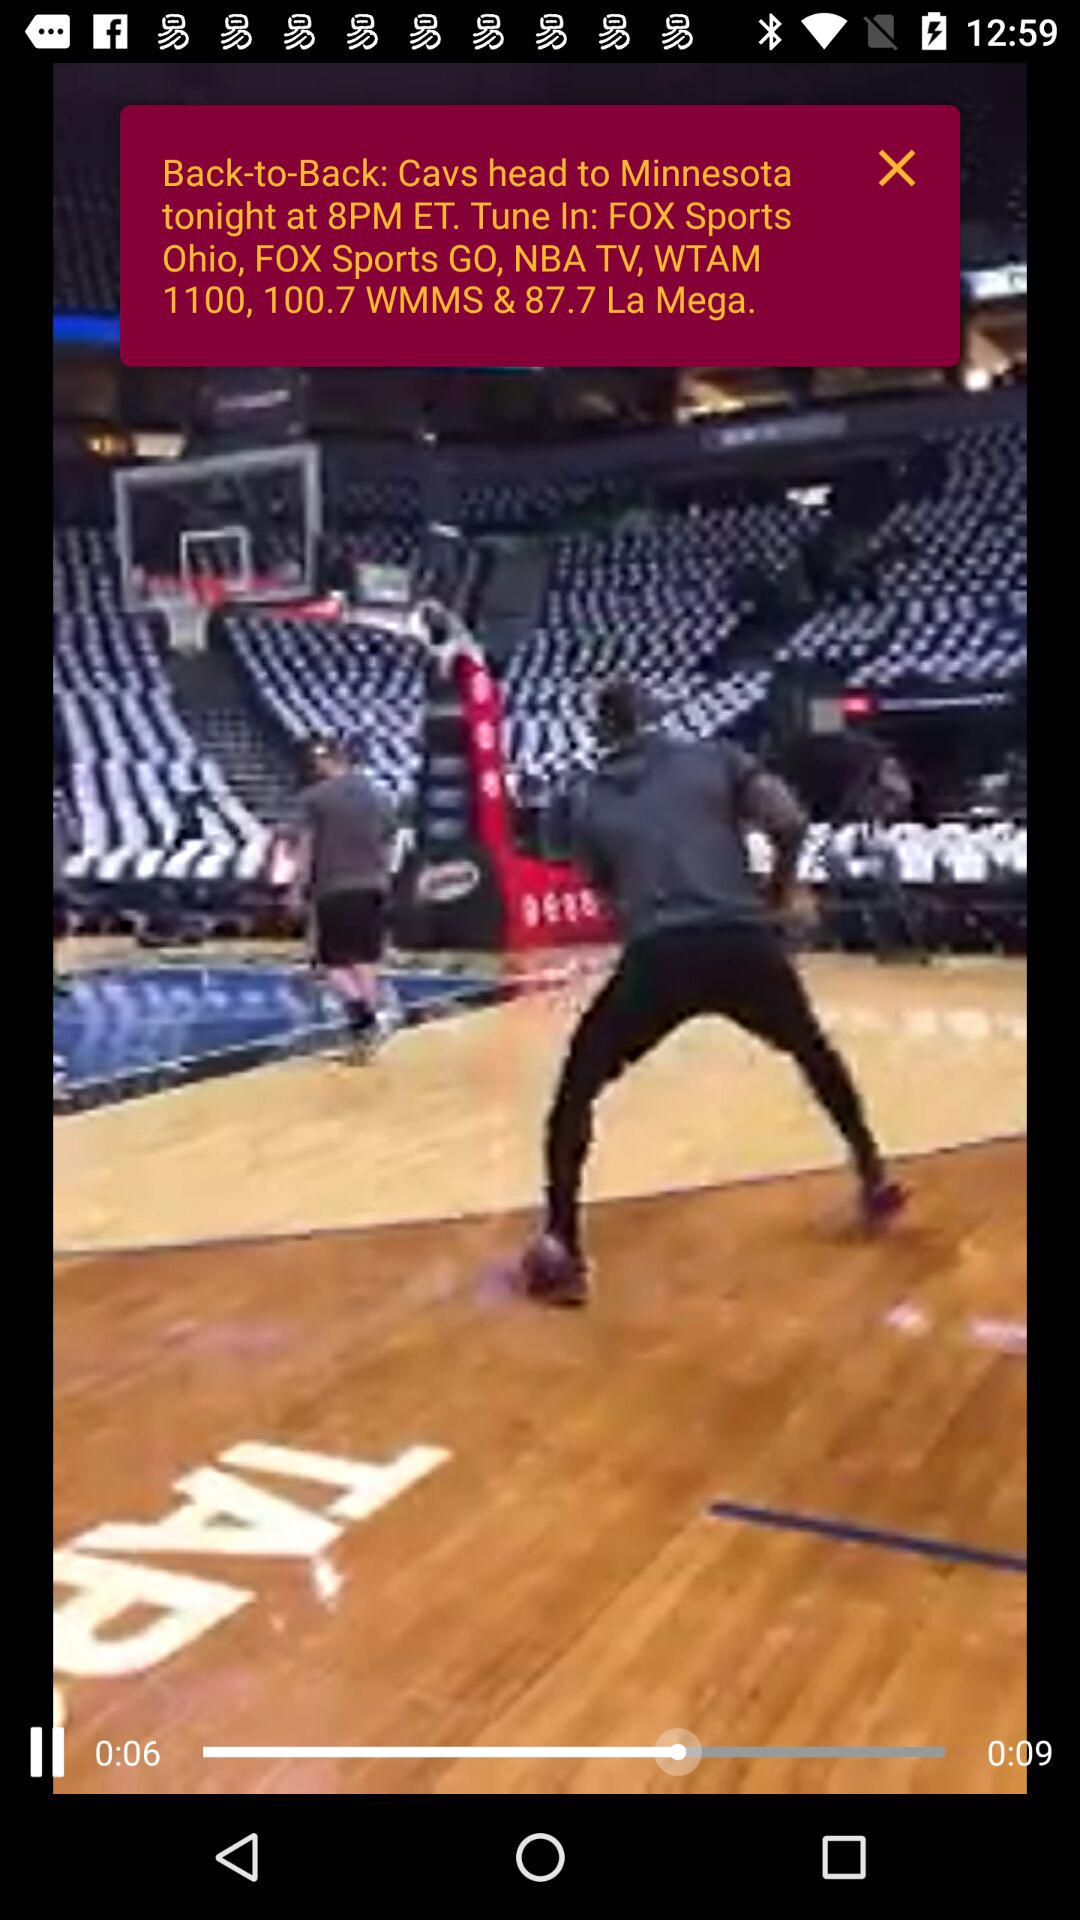How long has the video been playing? The video has been playing for 0:06 long. 